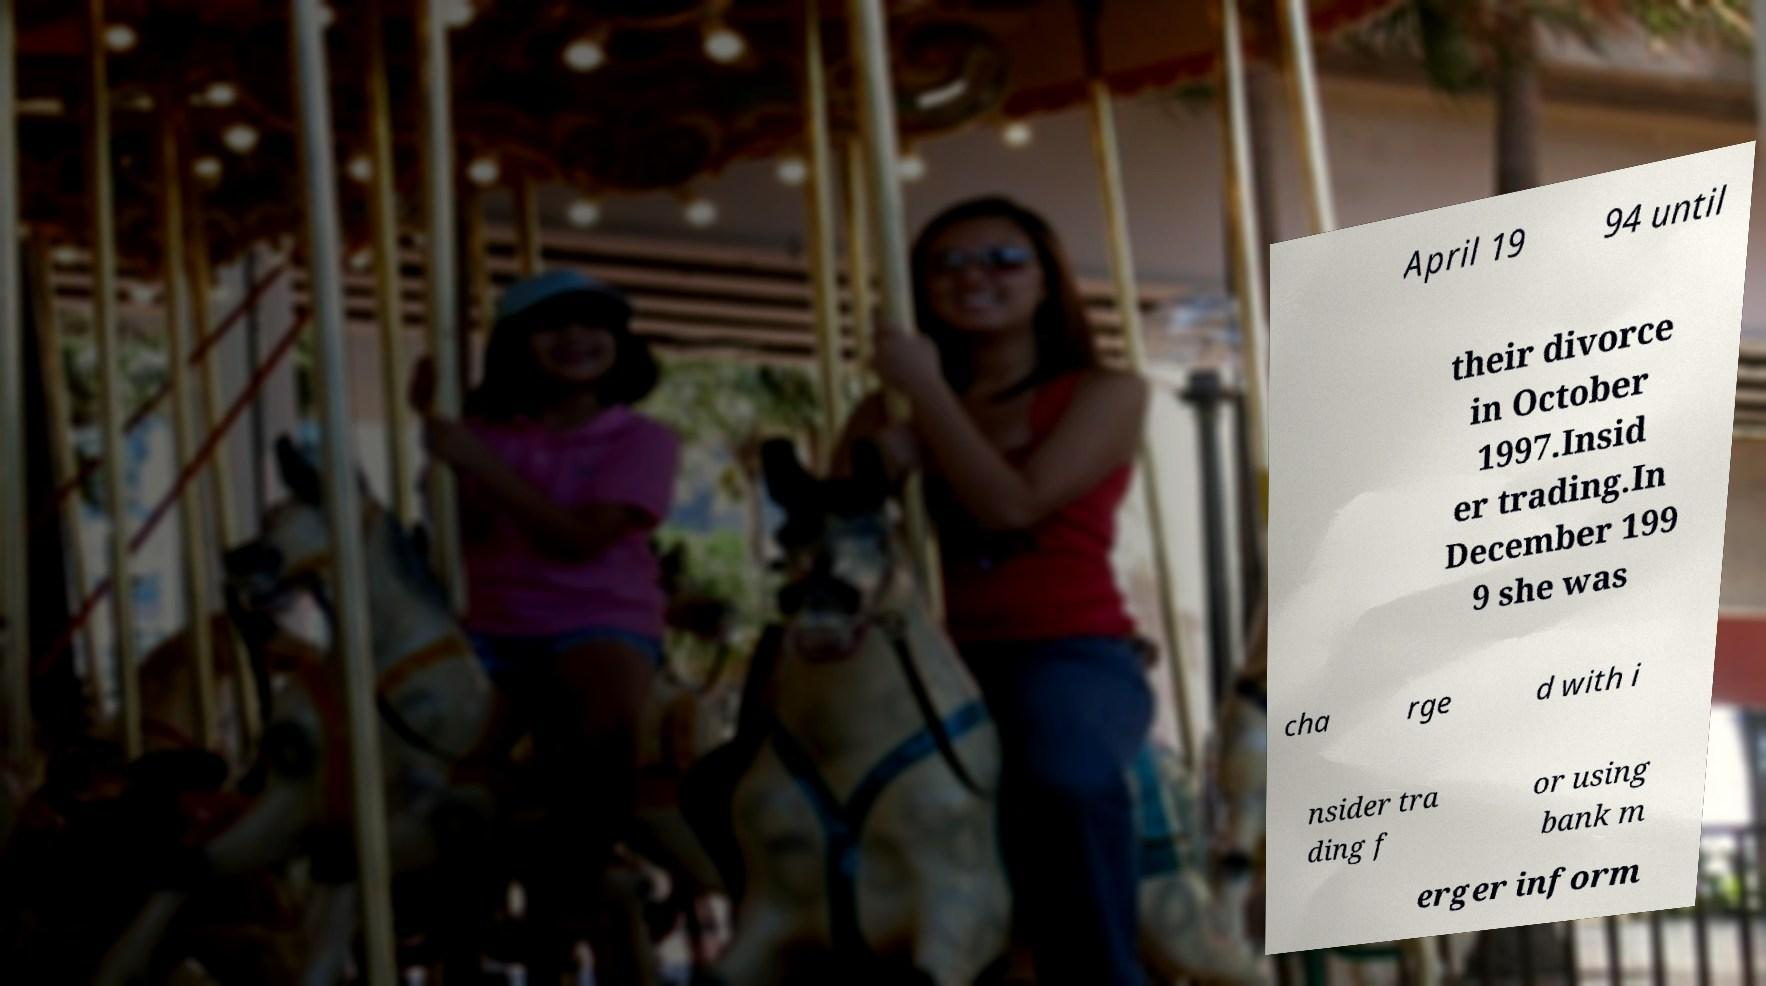I need the written content from this picture converted into text. Can you do that? April 19 94 until their divorce in October 1997.Insid er trading.In December 199 9 she was cha rge d with i nsider tra ding f or using bank m erger inform 